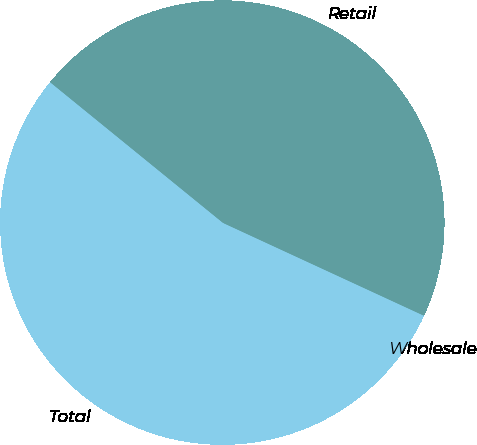<chart> <loc_0><loc_0><loc_500><loc_500><pie_chart><fcel>Wholesale<fcel>Retail<fcel>Total<nl><fcel>3.37%<fcel>46.01%<fcel>50.61%<nl></chart> 